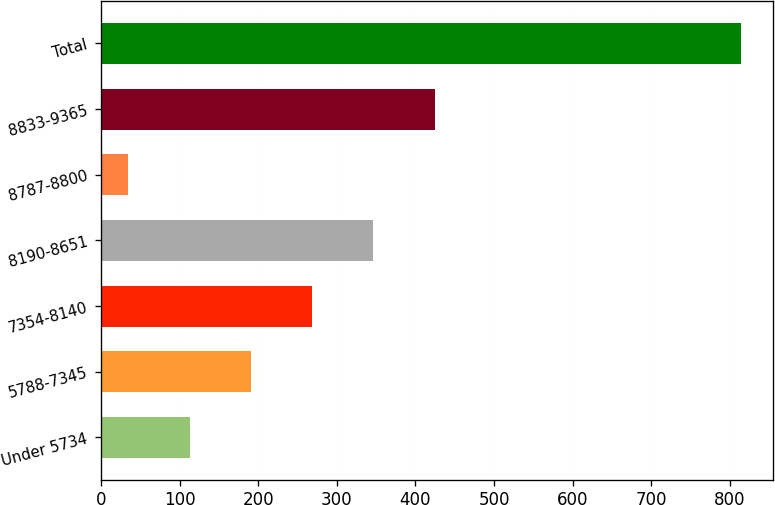Convert chart to OTSL. <chart><loc_0><loc_0><loc_500><loc_500><bar_chart><fcel>Under 5734<fcel>5788-7345<fcel>7354-8140<fcel>8190-8651<fcel>8787-8800<fcel>8833-9365<fcel>Total<nl><fcel>112.9<fcel>190.8<fcel>268.7<fcel>346.6<fcel>35<fcel>424.5<fcel>814<nl></chart> 